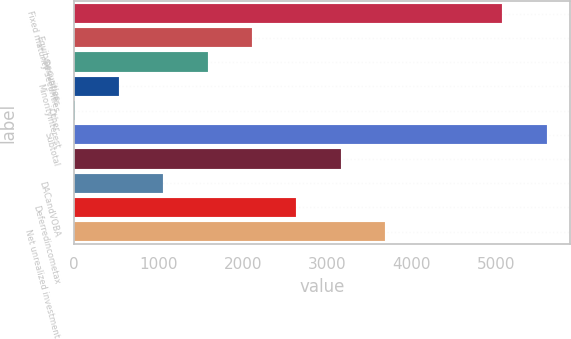Convert chart. <chart><loc_0><loc_0><loc_500><loc_500><bar_chart><fcel>Fixed maturity securities<fcel>Equitysecurities<fcel>Derivatives<fcel>Minorityinterest<fcel>Other<fcel>Subtotal<fcel>Unnamed: 6<fcel>DACandVOBA<fcel>Deferredincometax<fcel>Net unrealized investment<nl><fcel>5075<fcel>2108.6<fcel>1583.7<fcel>533.9<fcel>9<fcel>5599.9<fcel>3158.4<fcel>1058.8<fcel>2633.5<fcel>3683.3<nl></chart> 